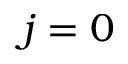<formula> <loc_0><loc_0><loc_500><loc_500>j = 0</formula> 